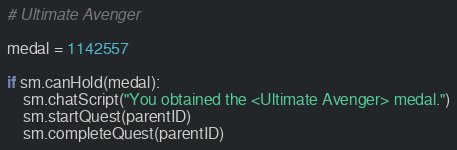Convert code to text. <code><loc_0><loc_0><loc_500><loc_500><_Python_># Ultimate Avenger

medal = 1142557

if sm.canHold(medal):
    sm.chatScript("You obtained the <Ultimate Avenger> medal.")
    sm.startQuest(parentID)
    sm.completeQuest(parentID)</code> 